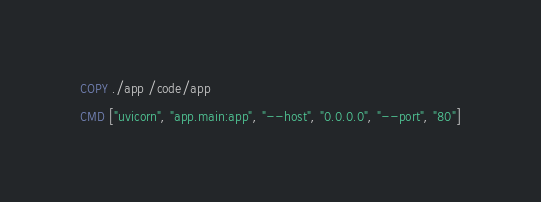Convert code to text. <code><loc_0><loc_0><loc_500><loc_500><_Dockerfile_>
COPY ./app /code/app

CMD ["uvicorn", "app.main:app", "--host", "0.0.0.0", "--port", "80"]</code> 